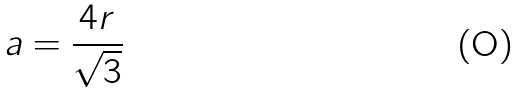Convert formula to latex. <formula><loc_0><loc_0><loc_500><loc_500>a = \frac { 4 r } { \sqrt { 3 } }</formula> 